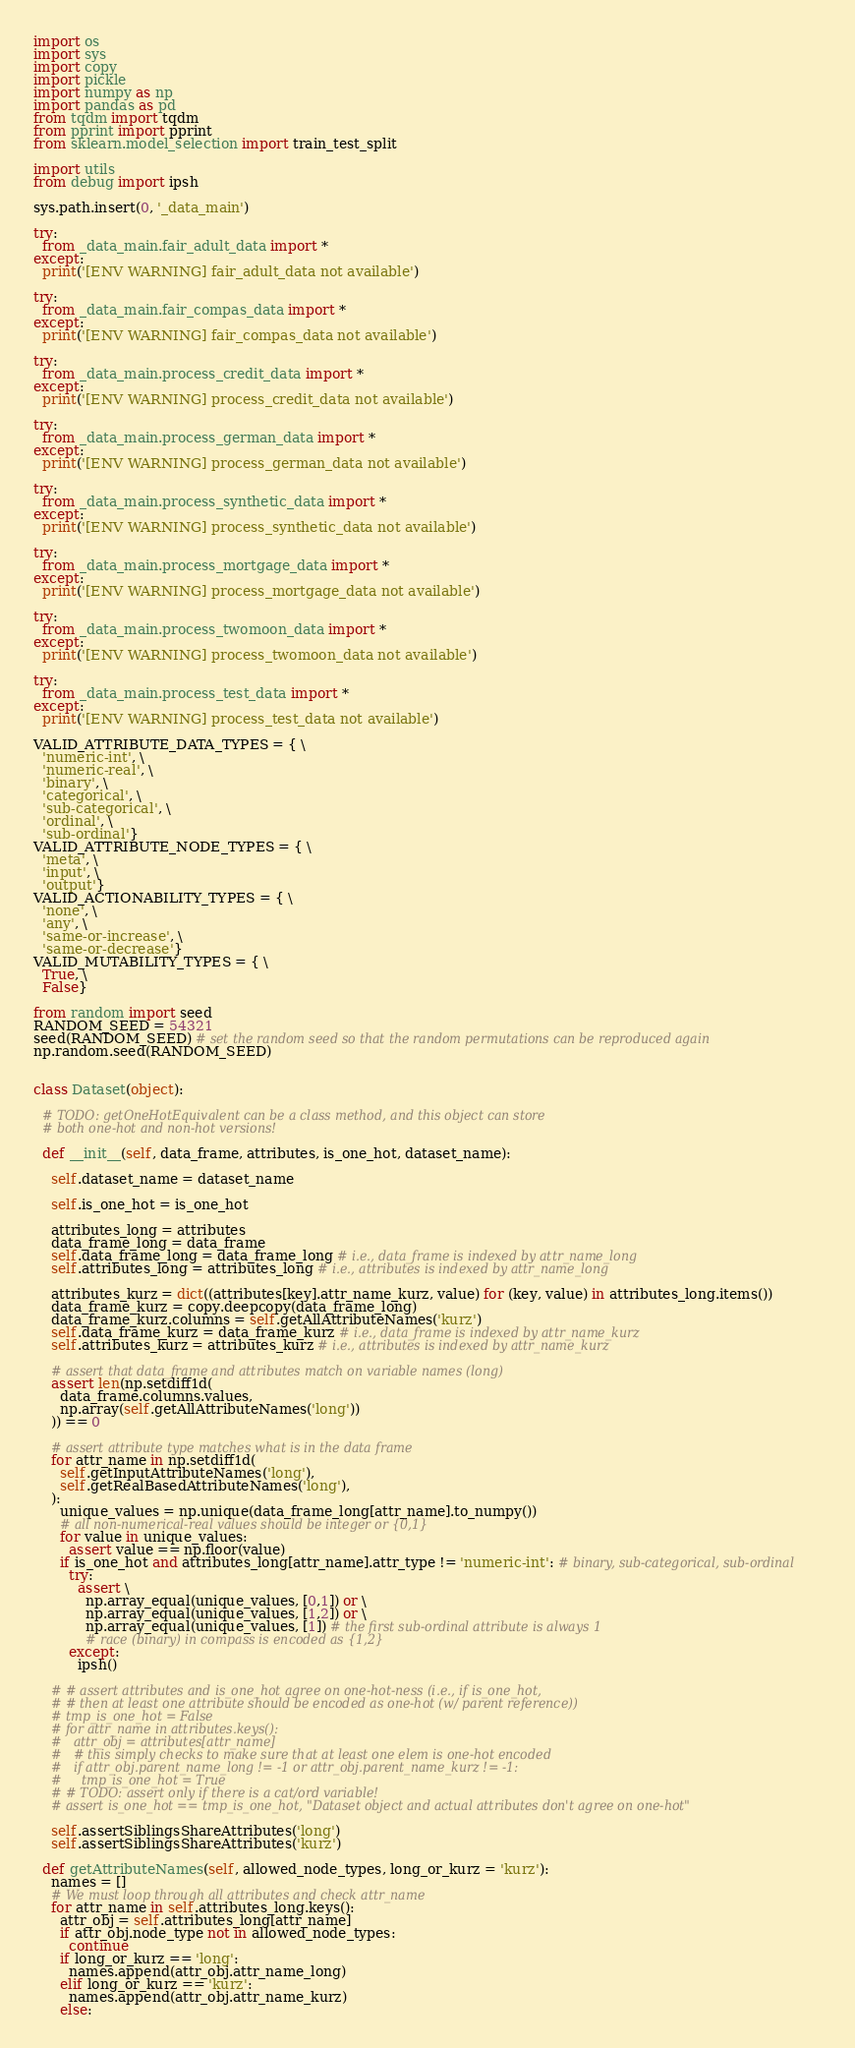Convert code to text. <code><loc_0><loc_0><loc_500><loc_500><_Python_>import os
import sys
import copy
import pickle
import numpy as np
import pandas as pd
from tqdm import tqdm
from pprint import pprint
from sklearn.model_selection import train_test_split

import utils
from debug import ipsh

sys.path.insert(0, '_data_main')

try:
  from _data_main.fair_adult_data import *
except:
  print('[ENV WARNING] fair_adult_data not available')

try:
  from _data_main.fair_compas_data import *
except:
  print('[ENV WARNING] fair_compas_data not available')

try:
  from _data_main.process_credit_data import *
except:
  print('[ENV WARNING] process_credit_data not available')

try:
  from _data_main.process_german_data import *
except:
  print('[ENV WARNING] process_german_data not available')

try:
  from _data_main.process_synthetic_data import *
except:
  print('[ENV WARNING] process_synthetic_data not available')

try:
  from _data_main.process_mortgage_data import *
except:
  print('[ENV WARNING] process_mortgage_data not available')

try:
  from _data_main.process_twomoon_data import *
except:
  print('[ENV WARNING] process_twomoon_data not available')

try:
  from _data_main.process_test_data import *
except:
  print('[ENV WARNING] process_test_data not available')

VALID_ATTRIBUTE_DATA_TYPES = { \
  'numeric-int', \
  'numeric-real', \
  'binary', \
  'categorical', \
  'sub-categorical', \
  'ordinal', \
  'sub-ordinal'}
VALID_ATTRIBUTE_NODE_TYPES = { \
  'meta', \
  'input', \
  'output'}
VALID_ACTIONABILITY_TYPES = { \
  'none', \
  'any', \
  'same-or-increase', \
  'same-or-decrease'}
VALID_MUTABILITY_TYPES = { \
  True, \
  False}

from random import seed
RANDOM_SEED = 54321
seed(RANDOM_SEED) # set the random seed so that the random permutations can be reproduced again
np.random.seed(RANDOM_SEED)


class Dataset(object):

  # TODO: getOneHotEquivalent can be a class method, and this object can store
  # both one-hot and non-hot versions!

  def __init__(self, data_frame, attributes, is_one_hot, dataset_name):

    self.dataset_name = dataset_name

    self.is_one_hot = is_one_hot

    attributes_long = attributes
    data_frame_long = data_frame
    self.data_frame_long = data_frame_long # i.e., data_frame is indexed by attr_name_long
    self.attributes_long = attributes_long # i.e., attributes is indexed by attr_name_long

    attributes_kurz = dict((attributes[key].attr_name_kurz, value) for (key, value) in attributes_long.items())
    data_frame_kurz = copy.deepcopy(data_frame_long)
    data_frame_kurz.columns = self.getAllAttributeNames('kurz')
    self.data_frame_kurz = data_frame_kurz # i.e., data_frame is indexed by attr_name_kurz
    self.attributes_kurz = attributes_kurz # i.e., attributes is indexed by attr_name_kurz

    # assert that data_frame and attributes match on variable names (long)
    assert len(np.setdiff1d(
      data_frame.columns.values,
      np.array(self.getAllAttributeNames('long'))
    )) == 0

    # assert attribute type matches what is in the data frame
    for attr_name in np.setdiff1d(
      self.getInputAttributeNames('long'),
      self.getRealBasedAttributeNames('long'),
    ):
      unique_values = np.unique(data_frame_long[attr_name].to_numpy())
      # all non-numerical-real values should be integer or {0,1}
      for value in unique_values:
        assert value == np.floor(value)
      if is_one_hot and attributes_long[attr_name].attr_type != 'numeric-int': # binary, sub-categorical, sub-ordinal
        try:
          assert \
            np.array_equal(unique_values, [0,1]) or \
            np.array_equal(unique_values, [1,2]) or \
            np.array_equal(unique_values, [1]) # the first sub-ordinal attribute is always 1
            # race (binary) in compass is encoded as {1,2}
        except:
          ipsh()

    # # assert attributes and is_one_hot agree on one-hot-ness (i.e., if is_one_hot,
    # # then at least one attribute should be encoded as one-hot (w/ parent reference))
    # tmp_is_one_hot = False
    # for attr_name in attributes.keys():
    #   attr_obj = attributes[attr_name]
    #   # this simply checks to make sure that at least one elem is one-hot encoded
    #   if attr_obj.parent_name_long != -1 or attr_obj.parent_name_kurz != -1:
    #     tmp_is_one_hot = True
    # # TODO: assert only if there is a cat/ord variable!
    # assert is_one_hot == tmp_is_one_hot, "Dataset object and actual attributes don't agree on one-hot"

    self.assertSiblingsShareAttributes('long')
    self.assertSiblingsShareAttributes('kurz')

  def getAttributeNames(self, allowed_node_types, long_or_kurz = 'kurz'):
    names = []
    # We must loop through all attributes and check attr_name
    for attr_name in self.attributes_long.keys():
      attr_obj = self.attributes_long[attr_name]
      if attr_obj.node_type not in allowed_node_types:
        continue
      if long_or_kurz == 'long':
        names.append(attr_obj.attr_name_long)
      elif long_or_kurz == 'kurz':
        names.append(attr_obj.attr_name_kurz)
      else:</code> 